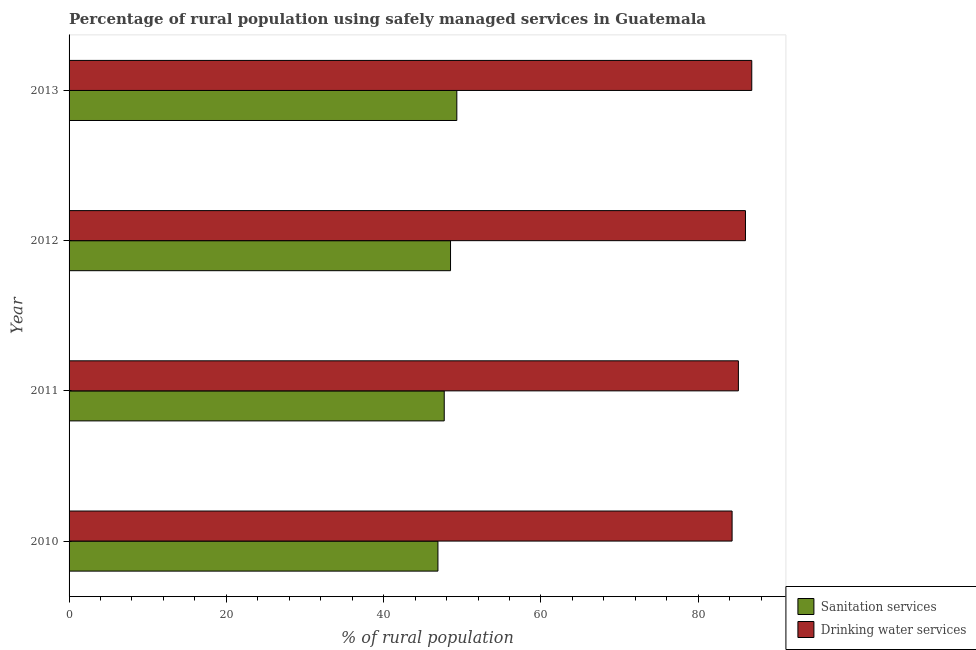How many different coloured bars are there?
Your response must be concise. 2. Are the number of bars per tick equal to the number of legend labels?
Your response must be concise. Yes. How many bars are there on the 1st tick from the top?
Your response must be concise. 2. In how many cases, is the number of bars for a given year not equal to the number of legend labels?
Provide a succinct answer. 0. What is the percentage of rural population who used sanitation services in 2012?
Provide a short and direct response. 48.5. Across all years, what is the maximum percentage of rural population who used drinking water services?
Your answer should be compact. 86.8. Across all years, what is the minimum percentage of rural population who used drinking water services?
Keep it short and to the point. 84.3. In which year was the percentage of rural population who used drinking water services maximum?
Provide a succinct answer. 2013. In which year was the percentage of rural population who used sanitation services minimum?
Ensure brevity in your answer.  2010. What is the total percentage of rural population who used drinking water services in the graph?
Provide a short and direct response. 342.2. What is the difference between the percentage of rural population who used sanitation services in 2010 and the percentage of rural population who used drinking water services in 2013?
Provide a succinct answer. -39.9. What is the average percentage of rural population who used sanitation services per year?
Ensure brevity in your answer.  48.1. In the year 2010, what is the difference between the percentage of rural population who used drinking water services and percentage of rural population who used sanitation services?
Provide a succinct answer. 37.4. In how many years, is the percentage of rural population who used drinking water services greater than 40 %?
Keep it short and to the point. 4. What is the ratio of the percentage of rural population who used drinking water services in 2011 to that in 2012?
Provide a succinct answer. 0.99. Is the percentage of rural population who used drinking water services in 2010 less than that in 2012?
Provide a short and direct response. Yes. Is the difference between the percentage of rural population who used drinking water services in 2010 and 2013 greater than the difference between the percentage of rural population who used sanitation services in 2010 and 2013?
Your response must be concise. No. What is the difference between the highest and the lowest percentage of rural population who used drinking water services?
Your answer should be compact. 2.5. In how many years, is the percentage of rural population who used sanitation services greater than the average percentage of rural population who used sanitation services taken over all years?
Ensure brevity in your answer.  2. Is the sum of the percentage of rural population who used drinking water services in 2010 and 2012 greater than the maximum percentage of rural population who used sanitation services across all years?
Provide a succinct answer. Yes. What does the 1st bar from the top in 2013 represents?
Keep it short and to the point. Drinking water services. What does the 2nd bar from the bottom in 2010 represents?
Your response must be concise. Drinking water services. How many bars are there?
Your response must be concise. 8. Are all the bars in the graph horizontal?
Give a very brief answer. Yes. Does the graph contain grids?
Your answer should be compact. No. What is the title of the graph?
Provide a succinct answer. Percentage of rural population using safely managed services in Guatemala. Does "Sanitation services" appear as one of the legend labels in the graph?
Your response must be concise. Yes. What is the label or title of the X-axis?
Ensure brevity in your answer.  % of rural population. What is the label or title of the Y-axis?
Provide a succinct answer. Year. What is the % of rural population in Sanitation services in 2010?
Offer a very short reply. 46.9. What is the % of rural population of Drinking water services in 2010?
Your answer should be compact. 84.3. What is the % of rural population in Sanitation services in 2011?
Keep it short and to the point. 47.7. What is the % of rural population of Drinking water services in 2011?
Your answer should be compact. 85.1. What is the % of rural population of Sanitation services in 2012?
Your answer should be very brief. 48.5. What is the % of rural population of Sanitation services in 2013?
Your response must be concise. 49.3. What is the % of rural population of Drinking water services in 2013?
Give a very brief answer. 86.8. Across all years, what is the maximum % of rural population of Sanitation services?
Offer a terse response. 49.3. Across all years, what is the maximum % of rural population of Drinking water services?
Offer a very short reply. 86.8. Across all years, what is the minimum % of rural population in Sanitation services?
Give a very brief answer. 46.9. Across all years, what is the minimum % of rural population in Drinking water services?
Give a very brief answer. 84.3. What is the total % of rural population of Sanitation services in the graph?
Make the answer very short. 192.4. What is the total % of rural population of Drinking water services in the graph?
Provide a short and direct response. 342.2. What is the difference between the % of rural population in Drinking water services in 2010 and that in 2011?
Offer a very short reply. -0.8. What is the difference between the % of rural population of Sanitation services in 2010 and that in 2012?
Your answer should be compact. -1.6. What is the difference between the % of rural population of Drinking water services in 2010 and that in 2012?
Give a very brief answer. -1.7. What is the difference between the % of rural population of Drinking water services in 2010 and that in 2013?
Your response must be concise. -2.5. What is the difference between the % of rural population of Sanitation services in 2011 and that in 2012?
Provide a succinct answer. -0.8. What is the difference between the % of rural population of Drinking water services in 2011 and that in 2012?
Your answer should be very brief. -0.9. What is the difference between the % of rural population of Sanitation services in 2011 and that in 2013?
Ensure brevity in your answer.  -1.6. What is the difference between the % of rural population of Drinking water services in 2011 and that in 2013?
Keep it short and to the point. -1.7. What is the difference between the % of rural population in Sanitation services in 2012 and that in 2013?
Provide a short and direct response. -0.8. What is the difference between the % of rural population of Drinking water services in 2012 and that in 2013?
Keep it short and to the point. -0.8. What is the difference between the % of rural population in Sanitation services in 2010 and the % of rural population in Drinking water services in 2011?
Your answer should be very brief. -38.2. What is the difference between the % of rural population in Sanitation services in 2010 and the % of rural population in Drinking water services in 2012?
Offer a very short reply. -39.1. What is the difference between the % of rural population in Sanitation services in 2010 and the % of rural population in Drinking water services in 2013?
Your answer should be very brief. -39.9. What is the difference between the % of rural population of Sanitation services in 2011 and the % of rural population of Drinking water services in 2012?
Provide a short and direct response. -38.3. What is the difference between the % of rural population of Sanitation services in 2011 and the % of rural population of Drinking water services in 2013?
Your answer should be compact. -39.1. What is the difference between the % of rural population in Sanitation services in 2012 and the % of rural population in Drinking water services in 2013?
Your answer should be very brief. -38.3. What is the average % of rural population of Sanitation services per year?
Offer a very short reply. 48.1. What is the average % of rural population of Drinking water services per year?
Provide a succinct answer. 85.55. In the year 2010, what is the difference between the % of rural population of Sanitation services and % of rural population of Drinking water services?
Give a very brief answer. -37.4. In the year 2011, what is the difference between the % of rural population of Sanitation services and % of rural population of Drinking water services?
Provide a short and direct response. -37.4. In the year 2012, what is the difference between the % of rural population of Sanitation services and % of rural population of Drinking water services?
Your answer should be very brief. -37.5. In the year 2013, what is the difference between the % of rural population in Sanitation services and % of rural population in Drinking water services?
Keep it short and to the point. -37.5. What is the ratio of the % of rural population in Sanitation services in 2010 to that in 2011?
Your response must be concise. 0.98. What is the ratio of the % of rural population in Drinking water services in 2010 to that in 2011?
Give a very brief answer. 0.99. What is the ratio of the % of rural population of Drinking water services in 2010 to that in 2012?
Ensure brevity in your answer.  0.98. What is the ratio of the % of rural population of Sanitation services in 2010 to that in 2013?
Offer a terse response. 0.95. What is the ratio of the % of rural population in Drinking water services in 2010 to that in 2013?
Keep it short and to the point. 0.97. What is the ratio of the % of rural population in Sanitation services in 2011 to that in 2012?
Provide a succinct answer. 0.98. What is the ratio of the % of rural population in Sanitation services in 2011 to that in 2013?
Your response must be concise. 0.97. What is the ratio of the % of rural population in Drinking water services in 2011 to that in 2013?
Offer a terse response. 0.98. What is the ratio of the % of rural population of Sanitation services in 2012 to that in 2013?
Make the answer very short. 0.98. What is the ratio of the % of rural population in Drinking water services in 2012 to that in 2013?
Provide a short and direct response. 0.99. What is the difference between the highest and the second highest % of rural population of Sanitation services?
Provide a succinct answer. 0.8. What is the difference between the highest and the second highest % of rural population in Drinking water services?
Your answer should be compact. 0.8. What is the difference between the highest and the lowest % of rural population of Sanitation services?
Give a very brief answer. 2.4. What is the difference between the highest and the lowest % of rural population of Drinking water services?
Keep it short and to the point. 2.5. 